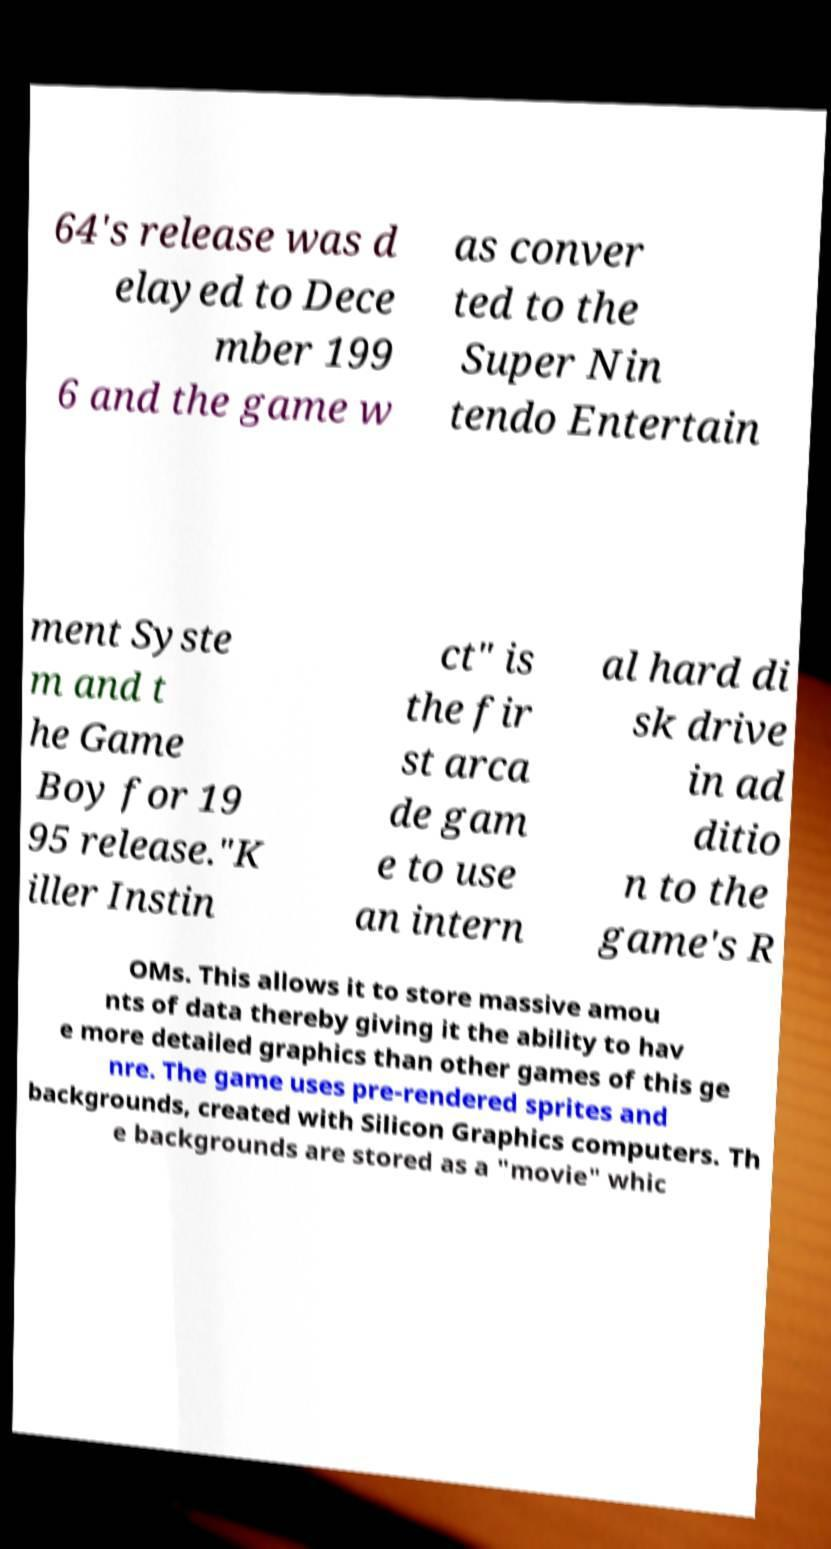Can you read and provide the text displayed in the image?This photo seems to have some interesting text. Can you extract and type it out for me? 64's release was d elayed to Dece mber 199 6 and the game w as conver ted to the Super Nin tendo Entertain ment Syste m and t he Game Boy for 19 95 release."K iller Instin ct" is the fir st arca de gam e to use an intern al hard di sk drive in ad ditio n to the game's R OMs. This allows it to store massive amou nts of data thereby giving it the ability to hav e more detailed graphics than other games of this ge nre. The game uses pre-rendered sprites and backgrounds, created with Silicon Graphics computers. Th e backgrounds are stored as a "movie" whic 